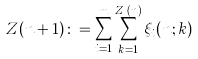Convert formula to latex. <formula><loc_0><loc_0><loc_500><loc_500>Z ( n + 1 ) \colon = \sum _ { i = 1 } ^ { m } \sum _ { k = 1 } ^ { Z _ { i } ( n ) } \xi _ { i } ( n ; k )</formula> 